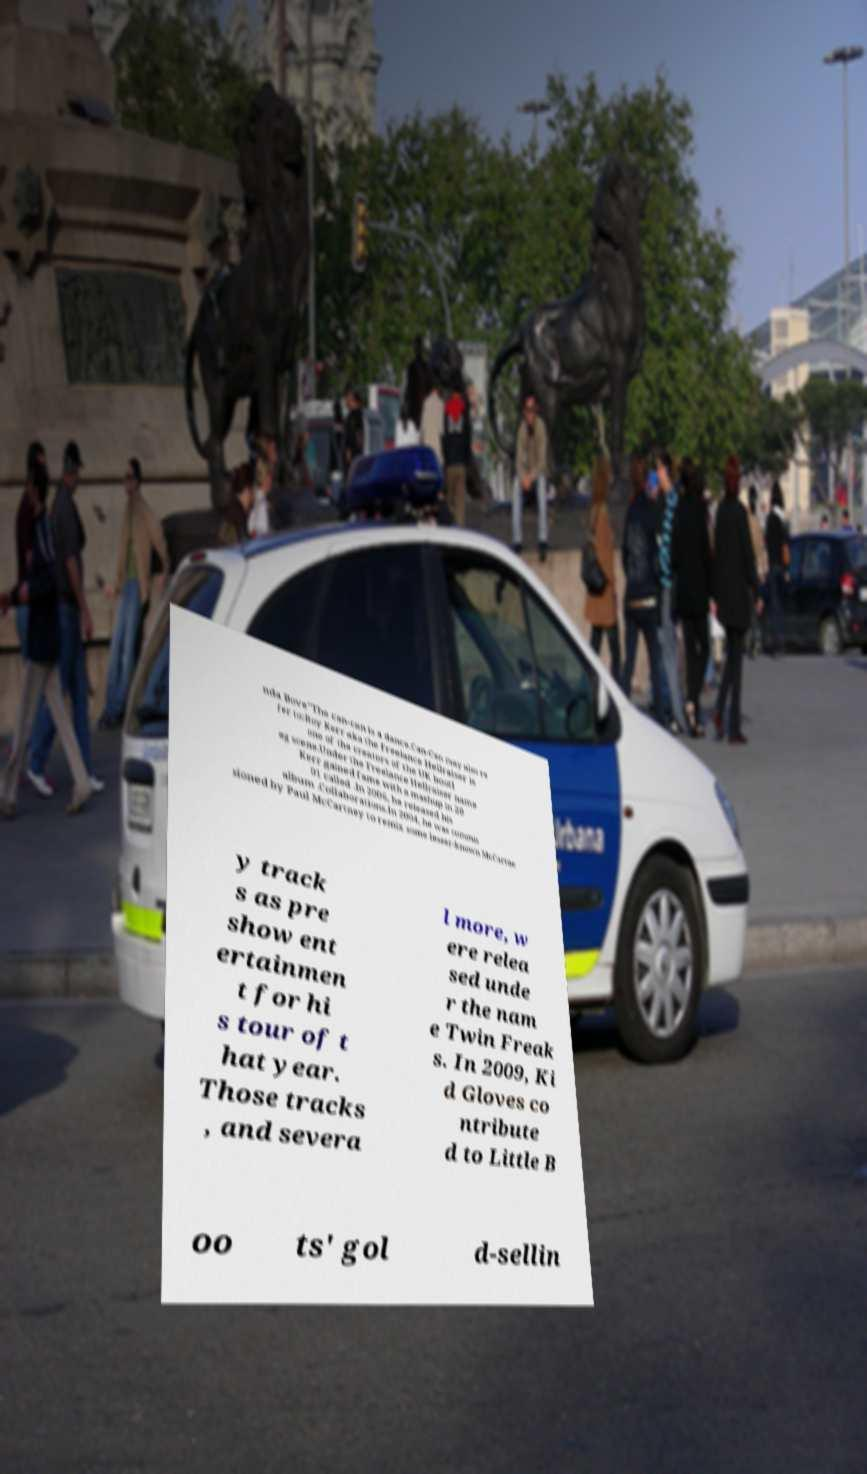Please identify and transcribe the text found in this image. nda Bove"The can-can is a dance.Can-Can may also re fer to:Roy Kerr aka the Freelance Hellraiser is one of the creators of the UK bootl eg scene.Under the Freelance Hellraiser name Kerr gained fame with a mashup in 20 01 called .In 2006, he released his album .Collaborations.In 2004, he was commis sioned by Paul McCartney to remix some lesser-known McCartne y track s as pre show ent ertainmen t for hi s tour of t hat year. Those tracks , and severa l more, w ere relea sed unde r the nam e Twin Freak s. In 2009, Ki d Gloves co ntribute d to Little B oo ts' gol d-sellin 